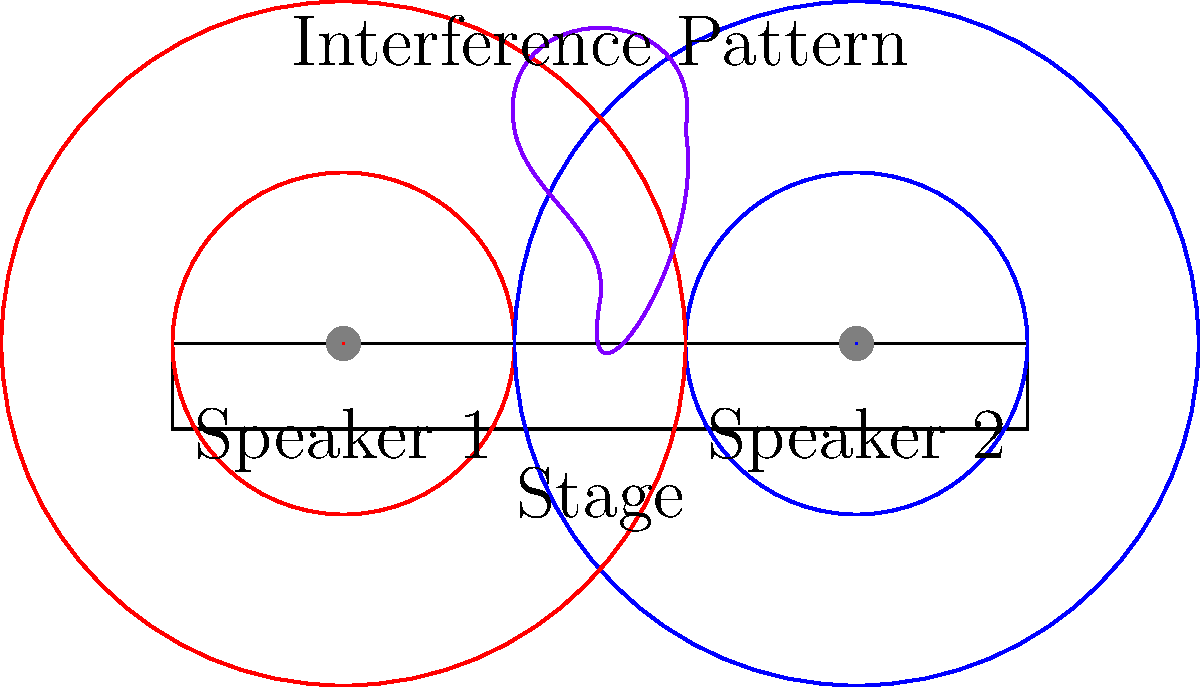As an opera singer, you're preparing for a performance where two speakers are placed 6 meters apart on the stage. If the speakers emit a pure tone with a wavelength of 2 meters, at what distance directly in front of the center of the stage will you experience the first constructive interference maximum? Let's approach this step-by-step:

1) For constructive interference, the path difference between waves from the two speakers must be a whole number of wavelengths. For the first maximum, this difference is one wavelength.

2) We can model this situation as a triangle, where:
   - The base is the distance between speakers (6 m)
   - The height is the distance from the stage to the point of interference
   - The two sides are the paths from each speaker to the interference point

3) Let's call the distance we're looking for $d$. Using the Pythagorean theorem:

   $$(3^2 + d^2) - ((3^2 + d^2) - 2^2) = 2^2$$

4) Simplifying:

   $$(9 + d^2) - (9 + d^2 - 4) = 4$$
   $$4 = 4$$

5) This confirms our setup is correct. Now, let's solve for $d$:

   $$\sqrt{9 + d^2} - \sqrt{9 + d^2 - 4} = 2$$

6) Square both sides:

   $$9 + d^2 + 9 + d^2 - 4 - 2\sqrt{(9 + d^2)(9 + d^2 - 4)} = 4$$

7) Simplify:

   $$18 + 2d^2 - 4 - 2\sqrt{(9 + d^2)(5 + d^2)} = 4$$
   $$2d^2 + 10 = 2\sqrt{(9 + d^2)(5 + d^2)}$$

8) Square both sides again:

   $$(2d^2 + 10)^2 = 4(9 + d^2)(5 + d^2)$$

9) Expand:

   $$4d^4 + 40d^2 + 100 = 4(45 + 14d^2 + d^4)$$
   $$4d^4 + 40d^2 + 100 = 180 + 56d^2 + 4d^4$$

10) The $4d^4$ terms cancel out:

    $$40d^2 + 100 = 180 + 56d^2$$
    $$-16d^2 = 80$$
    $$d^2 = 5$$

11) Take the square root:

    $$d = \sqrt{5} \approx 2.236$$

Therefore, the first constructive interference maximum occurs approximately 2.236 meters in front of the center of the stage.
Answer: $\sqrt{5}$ meters (approximately 2.236 meters) 